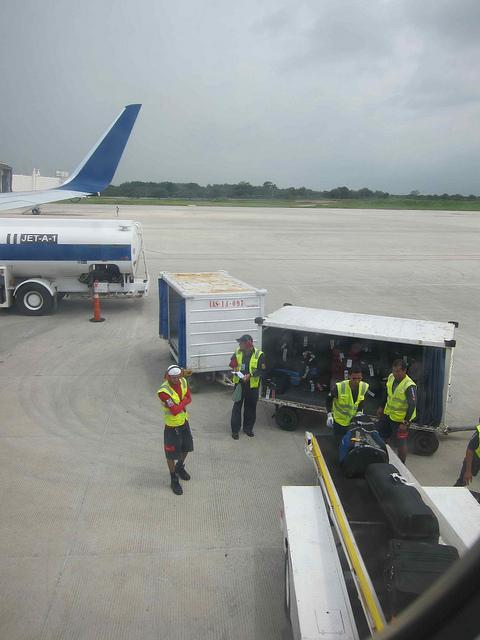What are they doing with the luggage?

Choices:
A) unloading
B) selling
C) stealing
D) loading unloading 